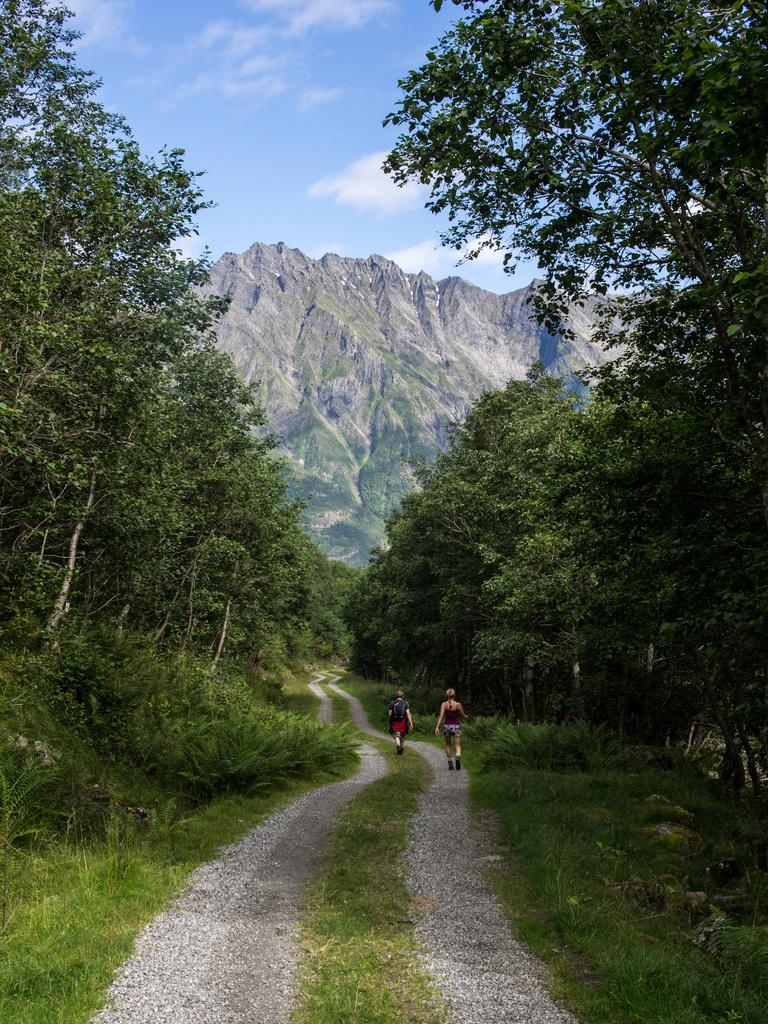How many people are walking in the image? There are two people walking in the image. What surface are the people walking on? The people are walking on a path. What type of vegetation can be seen in the image? There are trees, plants, and grass in the image. What type of landscape is visible in the background? There are mountains in the image. What is visible in the sky? There are clouds in the sky. What impulse did the visitor feel during the summer while looking at the mountains in the image? There is no visitor mentioned in the image, and no indication of any feelings or impulses. Additionally, the season is not specified, so we cannot assume it is summer. 